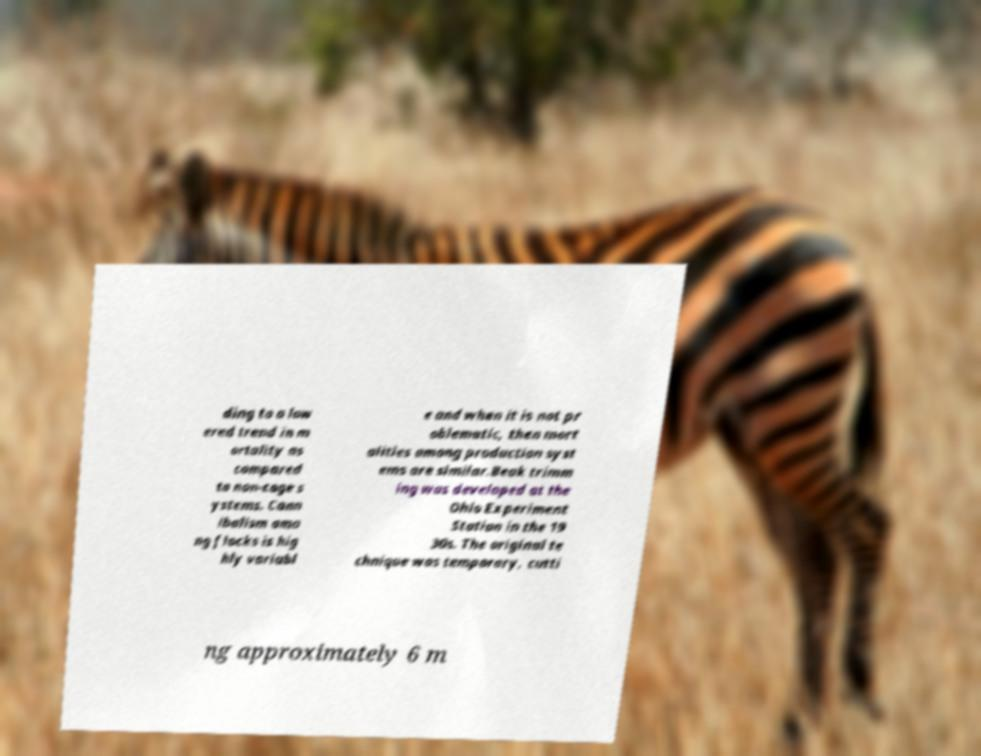Could you assist in decoding the text presented in this image and type it out clearly? ding to a low ered trend in m ortality as compared to non-cage s ystems. Cann ibalism amo ng flocks is hig hly variabl e and when it is not pr oblematic, then mort alities among production syst ems are similar.Beak trimm ing was developed at the Ohio Experiment Station in the 19 30s. The original te chnique was temporary, cutti ng approximately 6 m 